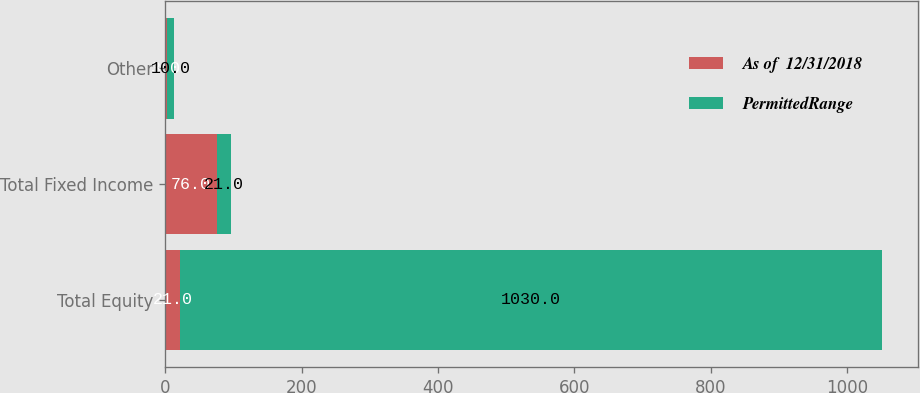Convert chart to OTSL. <chart><loc_0><loc_0><loc_500><loc_500><stacked_bar_chart><ecel><fcel>Total Equity<fcel>Total Fixed Income<fcel>Other<nl><fcel>As of  12/31/2018<fcel>21<fcel>76<fcel>3<nl><fcel>PermittedRange<fcel>1030<fcel>21<fcel>10<nl></chart> 